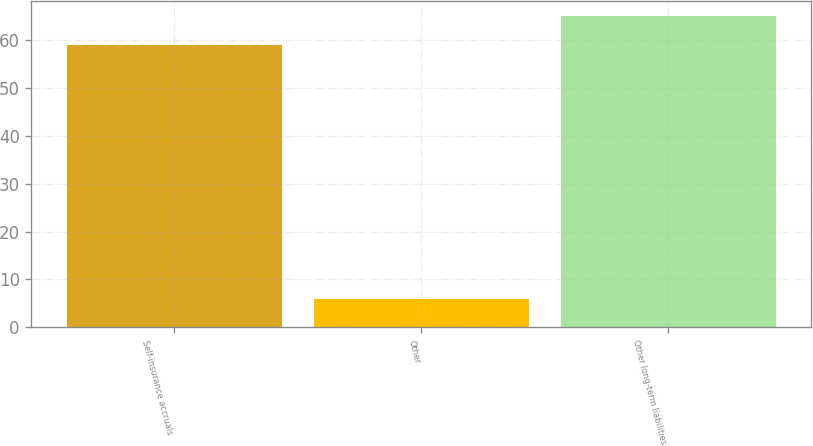Convert chart. <chart><loc_0><loc_0><loc_500><loc_500><bar_chart><fcel>Self-insurance accruals<fcel>Other<fcel>Other long-term liabilities<nl><fcel>59<fcel>6<fcel>65<nl></chart> 